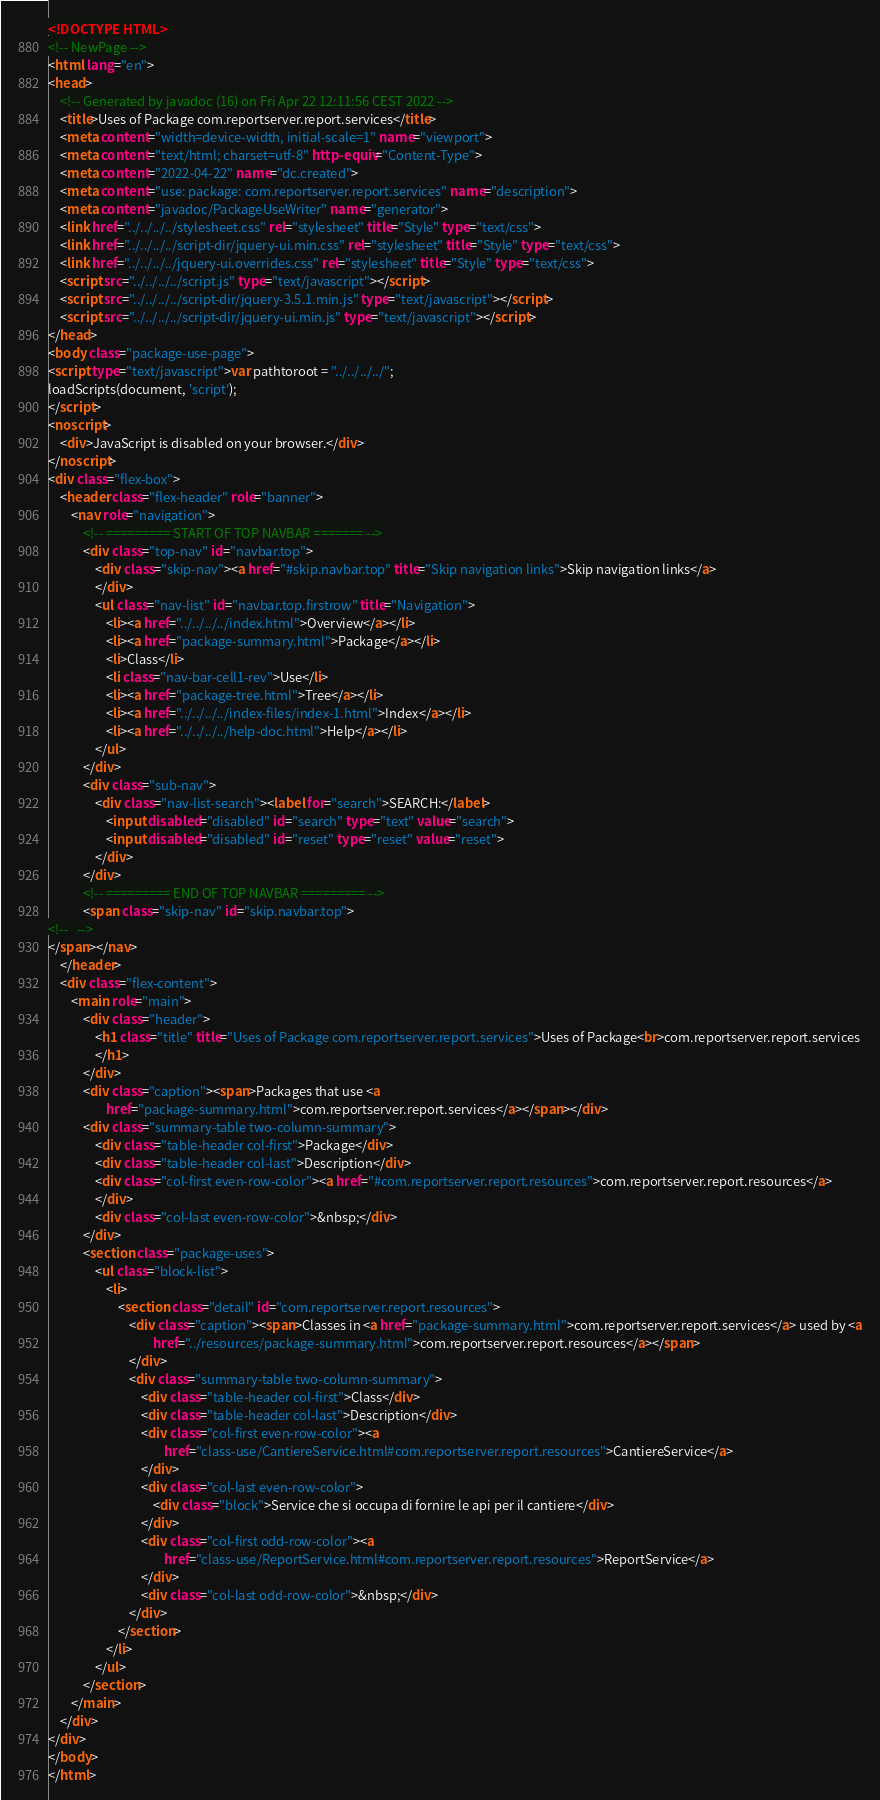<code> <loc_0><loc_0><loc_500><loc_500><_HTML_><!DOCTYPE HTML>
<!-- NewPage -->
<html lang="en">
<head>
    <!-- Generated by javadoc (16) on Fri Apr 22 12:11:56 CEST 2022 -->
    <title>Uses of Package com.reportserver.report.services</title>
    <meta content="width=device-width, initial-scale=1" name="viewport">
    <meta content="text/html; charset=utf-8" http-equiv="Content-Type">
    <meta content="2022-04-22" name="dc.created">
    <meta content="use: package: com.reportserver.report.services" name="description">
    <meta content="javadoc/PackageUseWriter" name="generator">
    <link href="../../../../stylesheet.css" rel="stylesheet" title="Style" type="text/css">
    <link href="../../../../script-dir/jquery-ui.min.css" rel="stylesheet" title="Style" type="text/css">
    <link href="../../../../jquery-ui.overrides.css" rel="stylesheet" title="Style" type="text/css">
    <script src="../../../../script.js" type="text/javascript"></script>
    <script src="../../../../script-dir/jquery-3.5.1.min.js" type="text/javascript"></script>
    <script src="../../../../script-dir/jquery-ui.min.js" type="text/javascript"></script>
</head>
<body class="package-use-page">
<script type="text/javascript">var pathtoroot = "../../../../";
loadScripts(document, 'script');
</script>
<noscript>
    <div>JavaScript is disabled on your browser.</div>
</noscript>
<div class="flex-box">
    <header class="flex-header" role="banner">
        <nav role="navigation">
            <!-- ========= START OF TOP NAVBAR ======= -->
            <div class="top-nav" id="navbar.top">
                <div class="skip-nav"><a href="#skip.navbar.top" title="Skip navigation links">Skip navigation links</a>
                </div>
                <ul class="nav-list" id="navbar.top.firstrow" title="Navigation">
                    <li><a href="../../../../index.html">Overview</a></li>
                    <li><a href="package-summary.html">Package</a></li>
                    <li>Class</li>
                    <li class="nav-bar-cell1-rev">Use</li>
                    <li><a href="package-tree.html">Tree</a></li>
                    <li><a href="../../../../index-files/index-1.html">Index</a></li>
                    <li><a href="../../../../help-doc.html">Help</a></li>
                </ul>
            </div>
            <div class="sub-nav">
                <div class="nav-list-search"><label for="search">SEARCH:</label>
                    <input disabled="disabled" id="search" type="text" value="search">
                    <input disabled="disabled" id="reset" type="reset" value="reset">
                </div>
            </div>
            <!-- ========= END OF TOP NAVBAR ========= -->
            <span class="skip-nav" id="skip.navbar.top">
<!--   -->
</span></nav>
    </header>
    <div class="flex-content">
        <main role="main">
            <div class="header">
                <h1 class="title" title="Uses of Package com.reportserver.report.services">Uses of Package<br>com.reportserver.report.services
                </h1>
            </div>
            <div class="caption"><span>Packages that use <a
                    href="package-summary.html">com.reportserver.report.services</a></span></div>
            <div class="summary-table two-column-summary">
                <div class="table-header col-first">Package</div>
                <div class="table-header col-last">Description</div>
                <div class="col-first even-row-color"><a href="#com.reportserver.report.resources">com.reportserver.report.resources</a>
                </div>
                <div class="col-last even-row-color">&nbsp;</div>
            </div>
            <section class="package-uses">
                <ul class="block-list">
                    <li>
                        <section class="detail" id="com.reportserver.report.resources">
                            <div class="caption"><span>Classes in <a href="package-summary.html">com.reportserver.report.services</a> used by <a
                                    href="../resources/package-summary.html">com.reportserver.report.resources</a></span>
                            </div>
                            <div class="summary-table two-column-summary">
                                <div class="table-header col-first">Class</div>
                                <div class="table-header col-last">Description</div>
                                <div class="col-first even-row-color"><a
                                        href="class-use/CantiereService.html#com.reportserver.report.resources">CantiereService</a>
                                </div>
                                <div class="col-last even-row-color">
                                    <div class="block">Service che si occupa di fornire le api per il cantiere</div>
                                </div>
                                <div class="col-first odd-row-color"><a
                                        href="class-use/ReportService.html#com.reportserver.report.resources">ReportService</a>
                                </div>
                                <div class="col-last odd-row-color">&nbsp;</div>
                            </div>
                        </section>
                    </li>
                </ul>
            </section>
        </main>
    </div>
</div>
</body>
</html>
</code> 